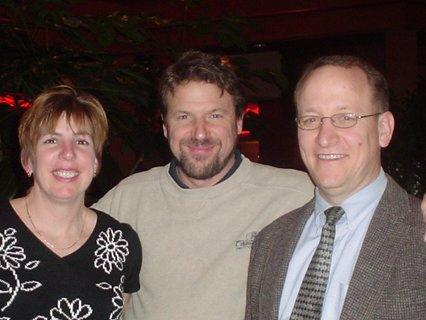The man in the middle has what feature?

Choices:
A) goatee
B) horns
C) third eye
D) triple chin goatee 